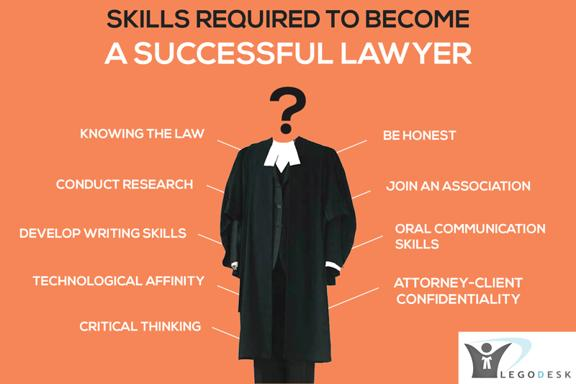How does 'Critical Thinking' influence a lawyer's ability to handle complex cases? Critical thinking is fundamental for lawyers as it enables them to analyze and interpret laws and evidence meticulously, foresee potential issues, and devise strategic solutions. This skill is particularly essential when dealing with intricate cases where the ability to evaluate different angles and outcomes can directly influence the effectiveness of the legal strategy and overall success in court. 